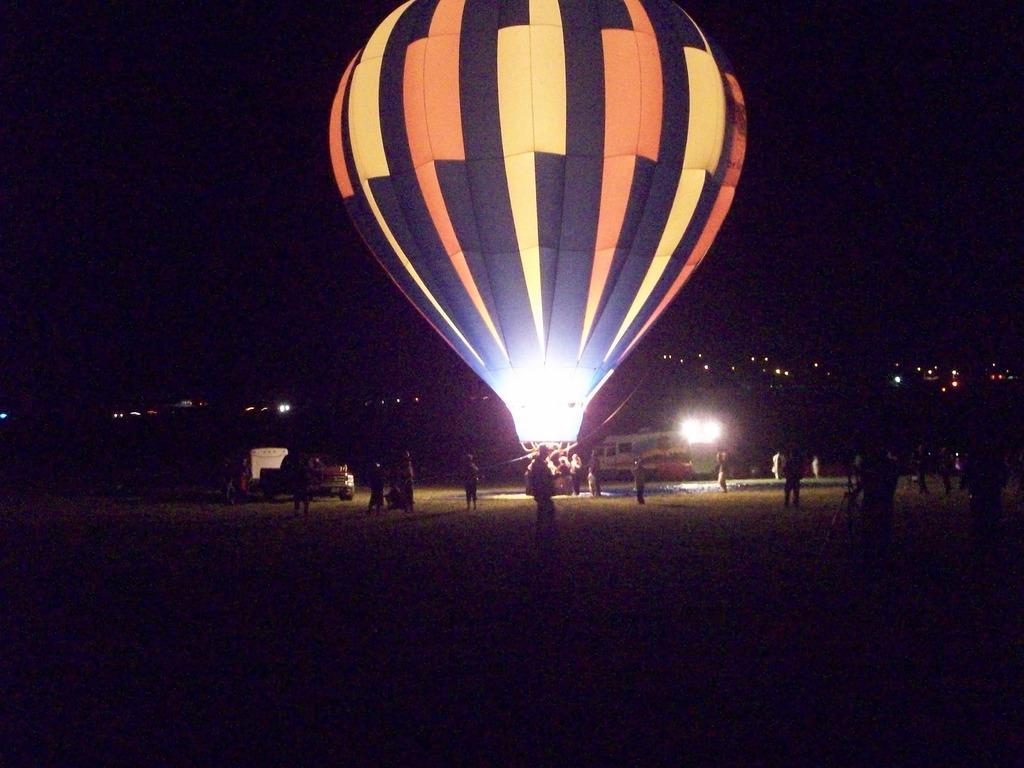Could you give a brief overview of what you see in this image? Background portion of the picture is completely dark. We can see the lights, vehicles. In this picture we can see the people and a hot air balloon. 